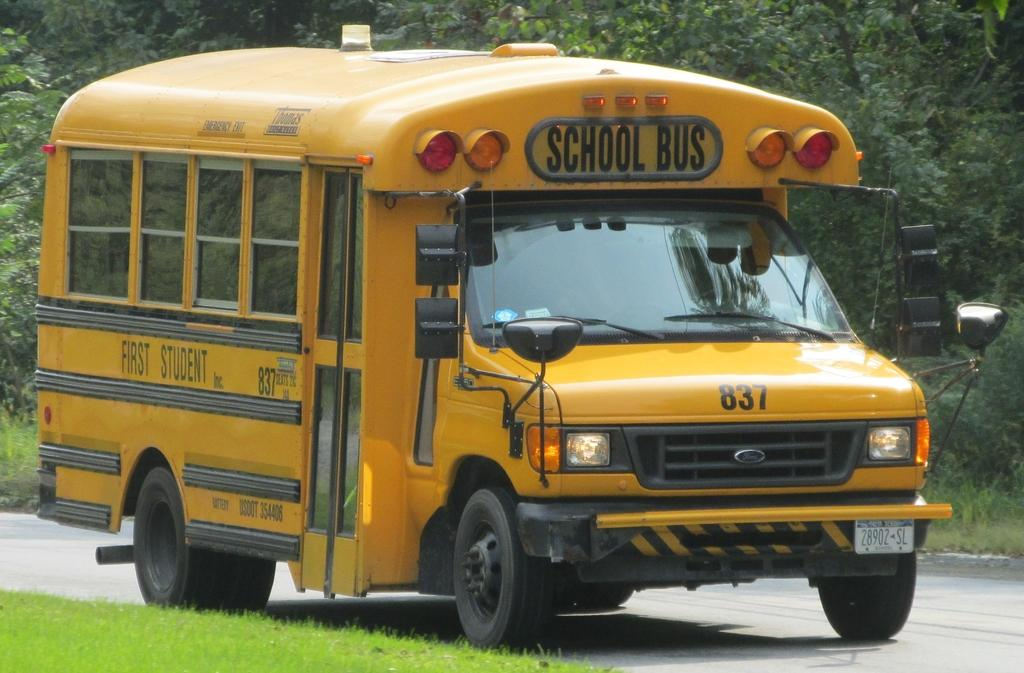What type of vehicle is on the road in the image? There is a school bus on the road in the image. What can be seen in the background of the image? There are trees in the background of the image. What type of vegetation is at the bottom of the image? There is grass at the bottom of the image. What type of hammer is hanging from the tree in the image? There is no hammer present in the image; it only features a school bus, trees, and grass. 